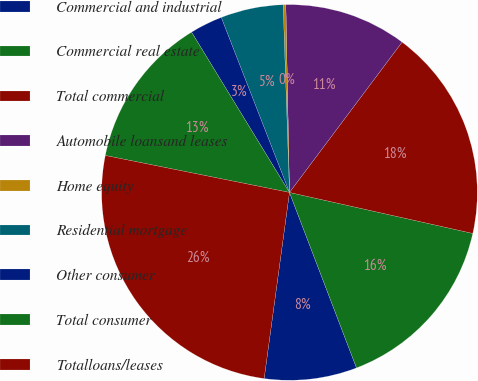Convert chart to OTSL. <chart><loc_0><loc_0><loc_500><loc_500><pie_chart><fcel>Commercial and industrial<fcel>Commercial real estate<fcel>Total commercial<fcel>Automobile loansand leases<fcel>Home equity<fcel>Residential mortgage<fcel>Other consumer<fcel>Total consumer<fcel>Totalloans/leases<nl><fcel>7.96%<fcel>15.69%<fcel>18.27%<fcel>10.54%<fcel>0.23%<fcel>5.38%<fcel>2.81%<fcel>13.12%<fcel>26.0%<nl></chart> 